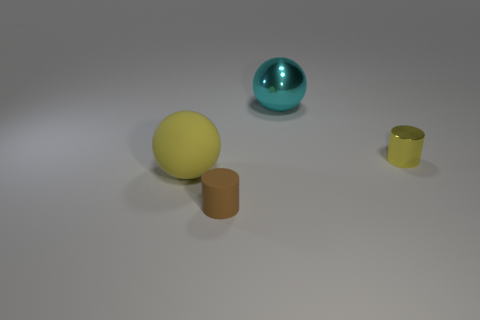How big is the object that is in front of the large cyan sphere and to the right of the brown thing?
Your answer should be very brief. Small. What material is the thing that is the same color as the big matte sphere?
Your answer should be compact. Metal. What is the material of the thing that is the same size as the yellow rubber ball?
Your response must be concise. Metal. Is the metal cylinder the same size as the matte ball?
Your answer should be compact. No. What is the material of the cylinder that is right of the cyan sphere?
Make the answer very short. Metal. There is another tiny yellow thing that is the same shape as the small matte object; what is it made of?
Provide a short and direct response. Metal. Are there any big balls that are behind the big thing that is on the left side of the large shiny object?
Ensure brevity in your answer.  Yes. Do the small yellow object and the big metal thing have the same shape?
Your answer should be very brief. No. The brown object that is the same material as the large yellow sphere is what shape?
Your response must be concise. Cylinder. Do the object that is in front of the yellow rubber object and the sphere that is in front of the large metal ball have the same size?
Provide a short and direct response. No. 